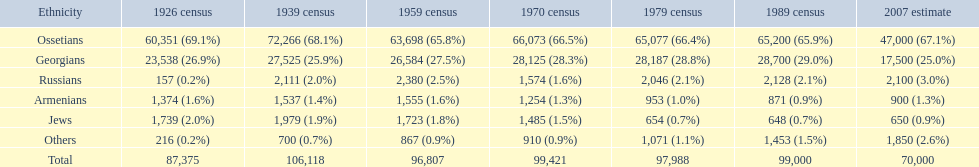Which ethnicity is at the pinnacle? Ossetians. 